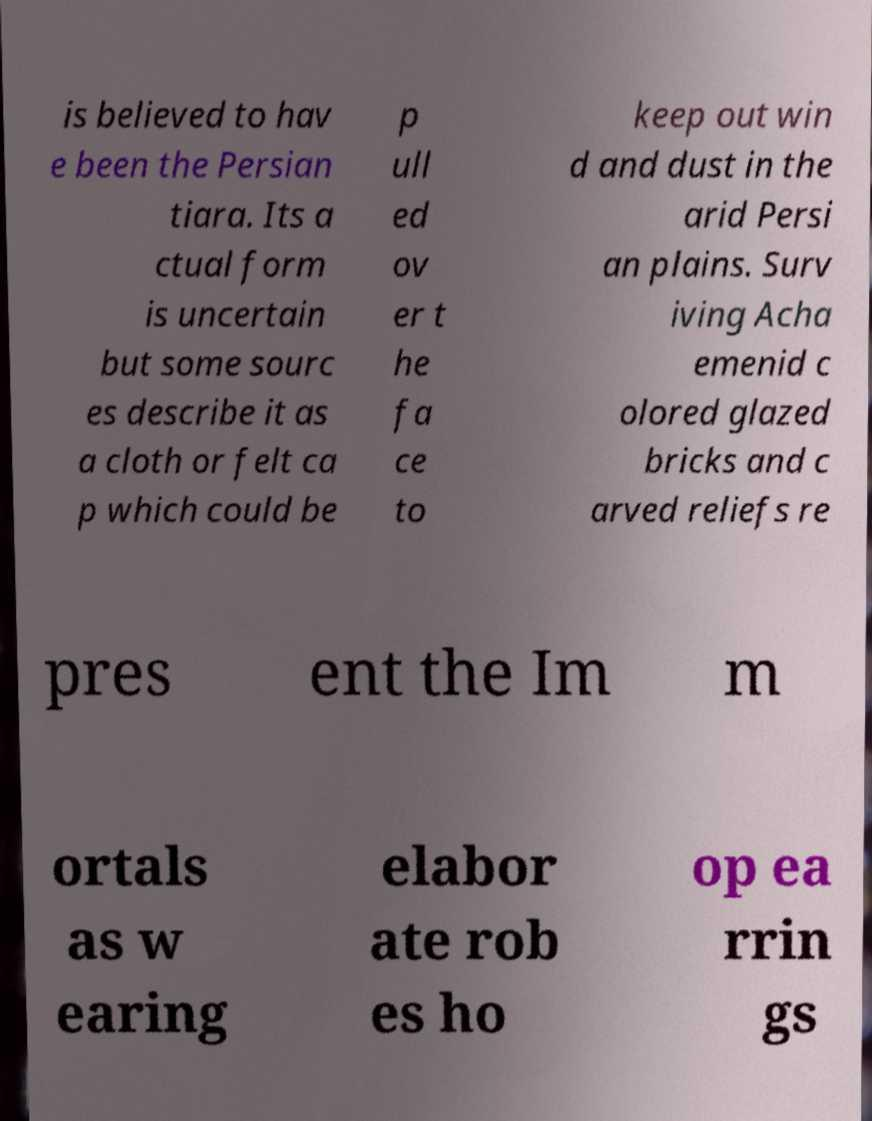I need the written content from this picture converted into text. Can you do that? is believed to hav e been the Persian tiara. Its a ctual form is uncertain but some sourc es describe it as a cloth or felt ca p which could be p ull ed ov er t he fa ce to keep out win d and dust in the arid Persi an plains. Surv iving Acha emenid c olored glazed bricks and c arved reliefs re pres ent the Im m ortals as w earing elabor ate rob es ho op ea rrin gs 